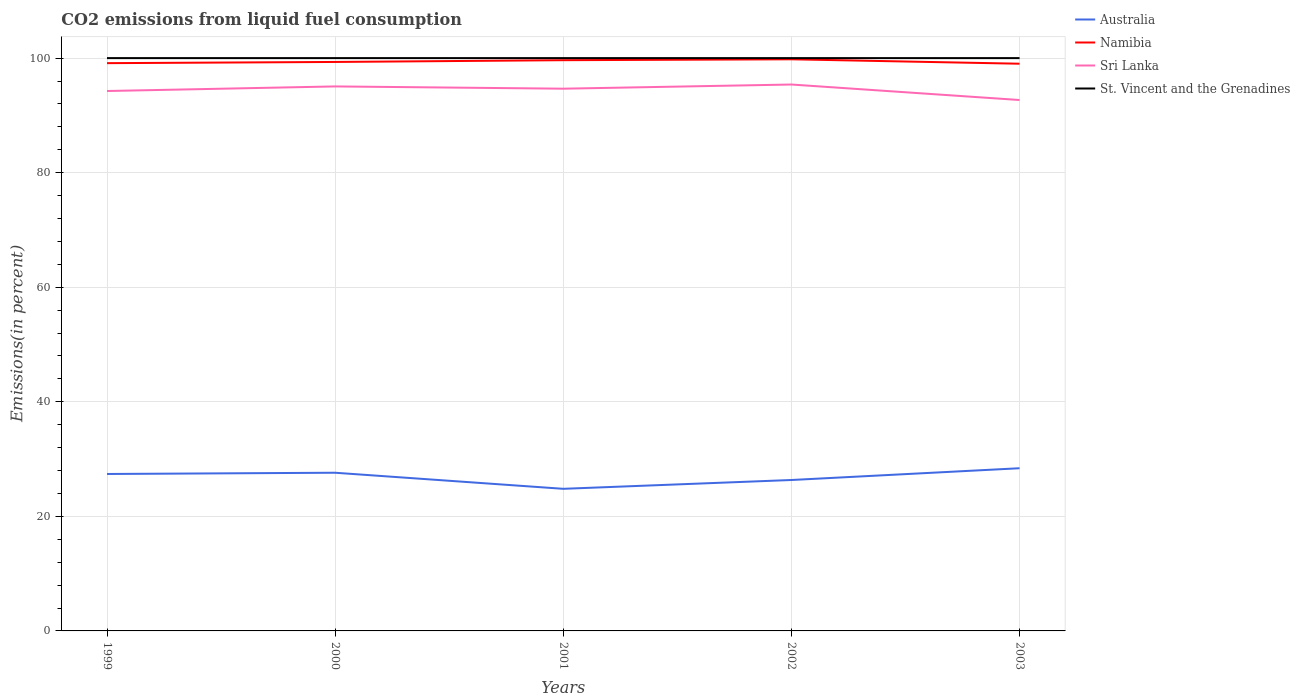How many different coloured lines are there?
Give a very brief answer. 4. Does the line corresponding to Australia intersect with the line corresponding to Namibia?
Your response must be concise. No. Is the number of lines equal to the number of legend labels?
Provide a succinct answer. Yes. Across all years, what is the maximum total CO2 emitted in Sri Lanka?
Ensure brevity in your answer.  92.68. In which year was the total CO2 emitted in St. Vincent and the Grenadines maximum?
Your answer should be compact. 1999. What is the total total CO2 emitted in St. Vincent and the Grenadines in the graph?
Your answer should be very brief. 0. Is the total CO2 emitted in Namibia strictly greater than the total CO2 emitted in St. Vincent and the Grenadines over the years?
Your answer should be compact. Yes. How many years are there in the graph?
Your response must be concise. 5. What is the difference between two consecutive major ticks on the Y-axis?
Give a very brief answer. 20. Are the values on the major ticks of Y-axis written in scientific E-notation?
Your response must be concise. No. Does the graph contain grids?
Provide a short and direct response. Yes. Where does the legend appear in the graph?
Provide a succinct answer. Top right. How many legend labels are there?
Keep it short and to the point. 4. What is the title of the graph?
Offer a very short reply. CO2 emissions from liquid fuel consumption. What is the label or title of the Y-axis?
Offer a very short reply. Emissions(in percent). What is the Emissions(in percent) of Australia in 1999?
Keep it short and to the point. 27.4. What is the Emissions(in percent) in Namibia in 1999?
Your response must be concise. 99.12. What is the Emissions(in percent) in Sri Lanka in 1999?
Make the answer very short. 94.26. What is the Emissions(in percent) in St. Vincent and the Grenadines in 1999?
Ensure brevity in your answer.  100. What is the Emissions(in percent) of Australia in 2000?
Provide a succinct answer. 27.61. What is the Emissions(in percent) of Namibia in 2000?
Offer a terse response. 99.33. What is the Emissions(in percent) of Sri Lanka in 2000?
Your response must be concise. 95.06. What is the Emissions(in percent) in Australia in 2001?
Keep it short and to the point. 24.81. What is the Emissions(in percent) in Namibia in 2001?
Provide a short and direct response. 99.64. What is the Emissions(in percent) in Sri Lanka in 2001?
Offer a terse response. 94.66. What is the Emissions(in percent) of St. Vincent and the Grenadines in 2001?
Offer a terse response. 100. What is the Emissions(in percent) in Australia in 2002?
Your answer should be compact. 26.35. What is the Emissions(in percent) of Namibia in 2002?
Your answer should be very brief. 99.79. What is the Emissions(in percent) of Sri Lanka in 2002?
Offer a terse response. 95.39. What is the Emissions(in percent) in St. Vincent and the Grenadines in 2002?
Provide a short and direct response. 100. What is the Emissions(in percent) of Australia in 2003?
Your answer should be compact. 28.4. What is the Emissions(in percent) of Namibia in 2003?
Your answer should be compact. 99.02. What is the Emissions(in percent) of Sri Lanka in 2003?
Provide a short and direct response. 92.68. Across all years, what is the maximum Emissions(in percent) in Australia?
Your response must be concise. 28.4. Across all years, what is the maximum Emissions(in percent) of Namibia?
Offer a very short reply. 99.79. Across all years, what is the maximum Emissions(in percent) of Sri Lanka?
Your response must be concise. 95.39. Across all years, what is the minimum Emissions(in percent) of Australia?
Ensure brevity in your answer.  24.81. Across all years, what is the minimum Emissions(in percent) of Namibia?
Your answer should be very brief. 99.02. Across all years, what is the minimum Emissions(in percent) in Sri Lanka?
Your answer should be very brief. 92.68. What is the total Emissions(in percent) of Australia in the graph?
Offer a very short reply. 134.57. What is the total Emissions(in percent) in Namibia in the graph?
Your answer should be compact. 496.9. What is the total Emissions(in percent) of Sri Lanka in the graph?
Provide a short and direct response. 472.05. What is the difference between the Emissions(in percent) of Australia in 1999 and that in 2000?
Your response must be concise. -0.22. What is the difference between the Emissions(in percent) in Namibia in 1999 and that in 2000?
Offer a terse response. -0.21. What is the difference between the Emissions(in percent) in Sri Lanka in 1999 and that in 2000?
Your answer should be very brief. -0.8. What is the difference between the Emissions(in percent) of St. Vincent and the Grenadines in 1999 and that in 2000?
Ensure brevity in your answer.  0. What is the difference between the Emissions(in percent) of Australia in 1999 and that in 2001?
Make the answer very short. 2.59. What is the difference between the Emissions(in percent) in Namibia in 1999 and that in 2001?
Offer a very short reply. -0.52. What is the difference between the Emissions(in percent) in Sri Lanka in 1999 and that in 2001?
Offer a very short reply. -0.41. What is the difference between the Emissions(in percent) in Australia in 1999 and that in 2002?
Your answer should be very brief. 1.05. What is the difference between the Emissions(in percent) of Namibia in 1999 and that in 2002?
Keep it short and to the point. -0.67. What is the difference between the Emissions(in percent) of Sri Lanka in 1999 and that in 2002?
Offer a very short reply. -1.13. What is the difference between the Emissions(in percent) of St. Vincent and the Grenadines in 1999 and that in 2002?
Your answer should be very brief. 0. What is the difference between the Emissions(in percent) in Australia in 1999 and that in 2003?
Provide a short and direct response. -1. What is the difference between the Emissions(in percent) of Namibia in 1999 and that in 2003?
Provide a succinct answer. 0.1. What is the difference between the Emissions(in percent) of Sri Lanka in 1999 and that in 2003?
Offer a terse response. 1.57. What is the difference between the Emissions(in percent) in St. Vincent and the Grenadines in 1999 and that in 2003?
Your answer should be compact. 0. What is the difference between the Emissions(in percent) of Australia in 2000 and that in 2001?
Your answer should be very brief. 2.81. What is the difference between the Emissions(in percent) of Namibia in 2000 and that in 2001?
Offer a very short reply. -0.31. What is the difference between the Emissions(in percent) in Sri Lanka in 2000 and that in 2001?
Make the answer very short. 0.39. What is the difference between the Emissions(in percent) of St. Vincent and the Grenadines in 2000 and that in 2001?
Your answer should be compact. 0. What is the difference between the Emissions(in percent) of Australia in 2000 and that in 2002?
Your response must be concise. 1.27. What is the difference between the Emissions(in percent) in Namibia in 2000 and that in 2002?
Make the answer very short. -0.46. What is the difference between the Emissions(in percent) in Sri Lanka in 2000 and that in 2002?
Keep it short and to the point. -0.33. What is the difference between the Emissions(in percent) in Australia in 2000 and that in 2003?
Your response must be concise. -0.79. What is the difference between the Emissions(in percent) in Namibia in 2000 and that in 2003?
Keep it short and to the point. 0.31. What is the difference between the Emissions(in percent) of Sri Lanka in 2000 and that in 2003?
Give a very brief answer. 2.37. What is the difference between the Emissions(in percent) of St. Vincent and the Grenadines in 2000 and that in 2003?
Your answer should be compact. 0. What is the difference between the Emissions(in percent) in Australia in 2001 and that in 2002?
Provide a succinct answer. -1.54. What is the difference between the Emissions(in percent) in Namibia in 2001 and that in 2002?
Your answer should be compact. -0.16. What is the difference between the Emissions(in percent) of Sri Lanka in 2001 and that in 2002?
Make the answer very short. -0.73. What is the difference between the Emissions(in percent) of St. Vincent and the Grenadines in 2001 and that in 2002?
Give a very brief answer. 0. What is the difference between the Emissions(in percent) in Australia in 2001 and that in 2003?
Ensure brevity in your answer.  -3.59. What is the difference between the Emissions(in percent) in Namibia in 2001 and that in 2003?
Ensure brevity in your answer.  0.61. What is the difference between the Emissions(in percent) of Sri Lanka in 2001 and that in 2003?
Ensure brevity in your answer.  1.98. What is the difference between the Emissions(in percent) of Australia in 2002 and that in 2003?
Give a very brief answer. -2.06. What is the difference between the Emissions(in percent) of Namibia in 2002 and that in 2003?
Provide a succinct answer. 0.77. What is the difference between the Emissions(in percent) of Sri Lanka in 2002 and that in 2003?
Provide a succinct answer. 2.71. What is the difference between the Emissions(in percent) in St. Vincent and the Grenadines in 2002 and that in 2003?
Ensure brevity in your answer.  0. What is the difference between the Emissions(in percent) in Australia in 1999 and the Emissions(in percent) in Namibia in 2000?
Ensure brevity in your answer.  -71.93. What is the difference between the Emissions(in percent) in Australia in 1999 and the Emissions(in percent) in Sri Lanka in 2000?
Your answer should be very brief. -67.66. What is the difference between the Emissions(in percent) in Australia in 1999 and the Emissions(in percent) in St. Vincent and the Grenadines in 2000?
Provide a short and direct response. -72.6. What is the difference between the Emissions(in percent) in Namibia in 1999 and the Emissions(in percent) in Sri Lanka in 2000?
Your answer should be very brief. 4.06. What is the difference between the Emissions(in percent) of Namibia in 1999 and the Emissions(in percent) of St. Vincent and the Grenadines in 2000?
Provide a short and direct response. -0.88. What is the difference between the Emissions(in percent) of Sri Lanka in 1999 and the Emissions(in percent) of St. Vincent and the Grenadines in 2000?
Your answer should be compact. -5.74. What is the difference between the Emissions(in percent) in Australia in 1999 and the Emissions(in percent) in Namibia in 2001?
Give a very brief answer. -72.24. What is the difference between the Emissions(in percent) in Australia in 1999 and the Emissions(in percent) in Sri Lanka in 2001?
Make the answer very short. -67.26. What is the difference between the Emissions(in percent) of Australia in 1999 and the Emissions(in percent) of St. Vincent and the Grenadines in 2001?
Your answer should be very brief. -72.6. What is the difference between the Emissions(in percent) in Namibia in 1999 and the Emissions(in percent) in Sri Lanka in 2001?
Ensure brevity in your answer.  4.46. What is the difference between the Emissions(in percent) of Namibia in 1999 and the Emissions(in percent) of St. Vincent and the Grenadines in 2001?
Offer a terse response. -0.88. What is the difference between the Emissions(in percent) in Sri Lanka in 1999 and the Emissions(in percent) in St. Vincent and the Grenadines in 2001?
Keep it short and to the point. -5.74. What is the difference between the Emissions(in percent) in Australia in 1999 and the Emissions(in percent) in Namibia in 2002?
Offer a very short reply. -72.39. What is the difference between the Emissions(in percent) in Australia in 1999 and the Emissions(in percent) in Sri Lanka in 2002?
Your answer should be compact. -67.99. What is the difference between the Emissions(in percent) of Australia in 1999 and the Emissions(in percent) of St. Vincent and the Grenadines in 2002?
Your response must be concise. -72.6. What is the difference between the Emissions(in percent) of Namibia in 1999 and the Emissions(in percent) of Sri Lanka in 2002?
Offer a terse response. 3.73. What is the difference between the Emissions(in percent) in Namibia in 1999 and the Emissions(in percent) in St. Vincent and the Grenadines in 2002?
Keep it short and to the point. -0.88. What is the difference between the Emissions(in percent) in Sri Lanka in 1999 and the Emissions(in percent) in St. Vincent and the Grenadines in 2002?
Your answer should be very brief. -5.74. What is the difference between the Emissions(in percent) in Australia in 1999 and the Emissions(in percent) in Namibia in 2003?
Your answer should be very brief. -71.62. What is the difference between the Emissions(in percent) in Australia in 1999 and the Emissions(in percent) in Sri Lanka in 2003?
Offer a very short reply. -65.29. What is the difference between the Emissions(in percent) of Australia in 1999 and the Emissions(in percent) of St. Vincent and the Grenadines in 2003?
Ensure brevity in your answer.  -72.6. What is the difference between the Emissions(in percent) in Namibia in 1999 and the Emissions(in percent) in Sri Lanka in 2003?
Your answer should be compact. 6.43. What is the difference between the Emissions(in percent) in Namibia in 1999 and the Emissions(in percent) in St. Vincent and the Grenadines in 2003?
Make the answer very short. -0.88. What is the difference between the Emissions(in percent) in Sri Lanka in 1999 and the Emissions(in percent) in St. Vincent and the Grenadines in 2003?
Offer a terse response. -5.74. What is the difference between the Emissions(in percent) of Australia in 2000 and the Emissions(in percent) of Namibia in 2001?
Give a very brief answer. -72.02. What is the difference between the Emissions(in percent) of Australia in 2000 and the Emissions(in percent) of Sri Lanka in 2001?
Provide a succinct answer. -67.05. What is the difference between the Emissions(in percent) in Australia in 2000 and the Emissions(in percent) in St. Vincent and the Grenadines in 2001?
Your response must be concise. -72.39. What is the difference between the Emissions(in percent) of Namibia in 2000 and the Emissions(in percent) of Sri Lanka in 2001?
Keep it short and to the point. 4.67. What is the difference between the Emissions(in percent) in Namibia in 2000 and the Emissions(in percent) in St. Vincent and the Grenadines in 2001?
Offer a very short reply. -0.67. What is the difference between the Emissions(in percent) in Sri Lanka in 2000 and the Emissions(in percent) in St. Vincent and the Grenadines in 2001?
Make the answer very short. -4.94. What is the difference between the Emissions(in percent) in Australia in 2000 and the Emissions(in percent) in Namibia in 2002?
Your answer should be very brief. -72.18. What is the difference between the Emissions(in percent) of Australia in 2000 and the Emissions(in percent) of Sri Lanka in 2002?
Give a very brief answer. -67.77. What is the difference between the Emissions(in percent) in Australia in 2000 and the Emissions(in percent) in St. Vincent and the Grenadines in 2002?
Ensure brevity in your answer.  -72.39. What is the difference between the Emissions(in percent) in Namibia in 2000 and the Emissions(in percent) in Sri Lanka in 2002?
Keep it short and to the point. 3.94. What is the difference between the Emissions(in percent) in Namibia in 2000 and the Emissions(in percent) in St. Vincent and the Grenadines in 2002?
Provide a succinct answer. -0.67. What is the difference between the Emissions(in percent) in Sri Lanka in 2000 and the Emissions(in percent) in St. Vincent and the Grenadines in 2002?
Keep it short and to the point. -4.94. What is the difference between the Emissions(in percent) in Australia in 2000 and the Emissions(in percent) in Namibia in 2003?
Give a very brief answer. -71.41. What is the difference between the Emissions(in percent) in Australia in 2000 and the Emissions(in percent) in Sri Lanka in 2003?
Offer a terse response. -65.07. What is the difference between the Emissions(in percent) in Australia in 2000 and the Emissions(in percent) in St. Vincent and the Grenadines in 2003?
Offer a terse response. -72.39. What is the difference between the Emissions(in percent) of Namibia in 2000 and the Emissions(in percent) of Sri Lanka in 2003?
Keep it short and to the point. 6.65. What is the difference between the Emissions(in percent) in Namibia in 2000 and the Emissions(in percent) in St. Vincent and the Grenadines in 2003?
Provide a short and direct response. -0.67. What is the difference between the Emissions(in percent) in Sri Lanka in 2000 and the Emissions(in percent) in St. Vincent and the Grenadines in 2003?
Your answer should be very brief. -4.94. What is the difference between the Emissions(in percent) in Australia in 2001 and the Emissions(in percent) in Namibia in 2002?
Your response must be concise. -74.98. What is the difference between the Emissions(in percent) in Australia in 2001 and the Emissions(in percent) in Sri Lanka in 2002?
Ensure brevity in your answer.  -70.58. What is the difference between the Emissions(in percent) in Australia in 2001 and the Emissions(in percent) in St. Vincent and the Grenadines in 2002?
Keep it short and to the point. -75.19. What is the difference between the Emissions(in percent) in Namibia in 2001 and the Emissions(in percent) in Sri Lanka in 2002?
Offer a terse response. 4.25. What is the difference between the Emissions(in percent) in Namibia in 2001 and the Emissions(in percent) in St. Vincent and the Grenadines in 2002?
Your response must be concise. -0.36. What is the difference between the Emissions(in percent) in Sri Lanka in 2001 and the Emissions(in percent) in St. Vincent and the Grenadines in 2002?
Offer a very short reply. -5.34. What is the difference between the Emissions(in percent) of Australia in 2001 and the Emissions(in percent) of Namibia in 2003?
Provide a succinct answer. -74.21. What is the difference between the Emissions(in percent) in Australia in 2001 and the Emissions(in percent) in Sri Lanka in 2003?
Provide a succinct answer. -67.88. What is the difference between the Emissions(in percent) in Australia in 2001 and the Emissions(in percent) in St. Vincent and the Grenadines in 2003?
Your response must be concise. -75.19. What is the difference between the Emissions(in percent) of Namibia in 2001 and the Emissions(in percent) of Sri Lanka in 2003?
Give a very brief answer. 6.95. What is the difference between the Emissions(in percent) in Namibia in 2001 and the Emissions(in percent) in St. Vincent and the Grenadines in 2003?
Your answer should be compact. -0.36. What is the difference between the Emissions(in percent) in Sri Lanka in 2001 and the Emissions(in percent) in St. Vincent and the Grenadines in 2003?
Ensure brevity in your answer.  -5.34. What is the difference between the Emissions(in percent) of Australia in 2002 and the Emissions(in percent) of Namibia in 2003?
Provide a short and direct response. -72.68. What is the difference between the Emissions(in percent) of Australia in 2002 and the Emissions(in percent) of Sri Lanka in 2003?
Make the answer very short. -66.34. What is the difference between the Emissions(in percent) of Australia in 2002 and the Emissions(in percent) of St. Vincent and the Grenadines in 2003?
Ensure brevity in your answer.  -73.65. What is the difference between the Emissions(in percent) in Namibia in 2002 and the Emissions(in percent) in Sri Lanka in 2003?
Provide a succinct answer. 7.11. What is the difference between the Emissions(in percent) of Namibia in 2002 and the Emissions(in percent) of St. Vincent and the Grenadines in 2003?
Offer a very short reply. -0.21. What is the difference between the Emissions(in percent) in Sri Lanka in 2002 and the Emissions(in percent) in St. Vincent and the Grenadines in 2003?
Your answer should be very brief. -4.61. What is the average Emissions(in percent) of Australia per year?
Your answer should be very brief. 26.91. What is the average Emissions(in percent) of Namibia per year?
Offer a terse response. 99.38. What is the average Emissions(in percent) of Sri Lanka per year?
Your response must be concise. 94.41. What is the average Emissions(in percent) in St. Vincent and the Grenadines per year?
Offer a terse response. 100. In the year 1999, what is the difference between the Emissions(in percent) in Australia and Emissions(in percent) in Namibia?
Make the answer very short. -71.72. In the year 1999, what is the difference between the Emissions(in percent) in Australia and Emissions(in percent) in Sri Lanka?
Offer a very short reply. -66.86. In the year 1999, what is the difference between the Emissions(in percent) of Australia and Emissions(in percent) of St. Vincent and the Grenadines?
Keep it short and to the point. -72.6. In the year 1999, what is the difference between the Emissions(in percent) in Namibia and Emissions(in percent) in Sri Lanka?
Offer a very short reply. 4.86. In the year 1999, what is the difference between the Emissions(in percent) of Namibia and Emissions(in percent) of St. Vincent and the Grenadines?
Your response must be concise. -0.88. In the year 1999, what is the difference between the Emissions(in percent) of Sri Lanka and Emissions(in percent) of St. Vincent and the Grenadines?
Offer a terse response. -5.74. In the year 2000, what is the difference between the Emissions(in percent) of Australia and Emissions(in percent) of Namibia?
Provide a succinct answer. -71.72. In the year 2000, what is the difference between the Emissions(in percent) in Australia and Emissions(in percent) in Sri Lanka?
Provide a short and direct response. -67.44. In the year 2000, what is the difference between the Emissions(in percent) in Australia and Emissions(in percent) in St. Vincent and the Grenadines?
Provide a succinct answer. -72.39. In the year 2000, what is the difference between the Emissions(in percent) of Namibia and Emissions(in percent) of Sri Lanka?
Offer a terse response. 4.27. In the year 2000, what is the difference between the Emissions(in percent) in Namibia and Emissions(in percent) in St. Vincent and the Grenadines?
Your answer should be very brief. -0.67. In the year 2000, what is the difference between the Emissions(in percent) of Sri Lanka and Emissions(in percent) of St. Vincent and the Grenadines?
Ensure brevity in your answer.  -4.94. In the year 2001, what is the difference between the Emissions(in percent) in Australia and Emissions(in percent) in Namibia?
Ensure brevity in your answer.  -74.83. In the year 2001, what is the difference between the Emissions(in percent) in Australia and Emissions(in percent) in Sri Lanka?
Offer a very short reply. -69.85. In the year 2001, what is the difference between the Emissions(in percent) of Australia and Emissions(in percent) of St. Vincent and the Grenadines?
Your answer should be very brief. -75.19. In the year 2001, what is the difference between the Emissions(in percent) of Namibia and Emissions(in percent) of Sri Lanka?
Make the answer very short. 4.97. In the year 2001, what is the difference between the Emissions(in percent) of Namibia and Emissions(in percent) of St. Vincent and the Grenadines?
Offer a very short reply. -0.36. In the year 2001, what is the difference between the Emissions(in percent) of Sri Lanka and Emissions(in percent) of St. Vincent and the Grenadines?
Your answer should be compact. -5.34. In the year 2002, what is the difference between the Emissions(in percent) of Australia and Emissions(in percent) of Namibia?
Your answer should be compact. -73.45. In the year 2002, what is the difference between the Emissions(in percent) in Australia and Emissions(in percent) in Sri Lanka?
Offer a very short reply. -69.04. In the year 2002, what is the difference between the Emissions(in percent) of Australia and Emissions(in percent) of St. Vincent and the Grenadines?
Provide a short and direct response. -73.65. In the year 2002, what is the difference between the Emissions(in percent) in Namibia and Emissions(in percent) in Sri Lanka?
Offer a very short reply. 4.4. In the year 2002, what is the difference between the Emissions(in percent) of Namibia and Emissions(in percent) of St. Vincent and the Grenadines?
Make the answer very short. -0.21. In the year 2002, what is the difference between the Emissions(in percent) of Sri Lanka and Emissions(in percent) of St. Vincent and the Grenadines?
Your answer should be compact. -4.61. In the year 2003, what is the difference between the Emissions(in percent) of Australia and Emissions(in percent) of Namibia?
Offer a very short reply. -70.62. In the year 2003, what is the difference between the Emissions(in percent) of Australia and Emissions(in percent) of Sri Lanka?
Give a very brief answer. -64.28. In the year 2003, what is the difference between the Emissions(in percent) in Australia and Emissions(in percent) in St. Vincent and the Grenadines?
Offer a terse response. -71.6. In the year 2003, what is the difference between the Emissions(in percent) in Namibia and Emissions(in percent) in Sri Lanka?
Keep it short and to the point. 6.34. In the year 2003, what is the difference between the Emissions(in percent) of Namibia and Emissions(in percent) of St. Vincent and the Grenadines?
Your answer should be very brief. -0.98. In the year 2003, what is the difference between the Emissions(in percent) in Sri Lanka and Emissions(in percent) in St. Vincent and the Grenadines?
Ensure brevity in your answer.  -7.32. What is the ratio of the Emissions(in percent) in Australia in 1999 to that in 2001?
Offer a terse response. 1.1. What is the ratio of the Emissions(in percent) in Namibia in 1999 to that in 2001?
Offer a very short reply. 0.99. What is the ratio of the Emissions(in percent) in Australia in 1999 to that in 2002?
Give a very brief answer. 1.04. What is the ratio of the Emissions(in percent) of Sri Lanka in 1999 to that in 2002?
Your answer should be very brief. 0.99. What is the ratio of the Emissions(in percent) of Australia in 1999 to that in 2003?
Provide a short and direct response. 0.96. What is the ratio of the Emissions(in percent) of Namibia in 1999 to that in 2003?
Ensure brevity in your answer.  1. What is the ratio of the Emissions(in percent) of Sri Lanka in 1999 to that in 2003?
Offer a very short reply. 1.02. What is the ratio of the Emissions(in percent) of St. Vincent and the Grenadines in 1999 to that in 2003?
Offer a very short reply. 1. What is the ratio of the Emissions(in percent) in Australia in 2000 to that in 2001?
Offer a terse response. 1.11. What is the ratio of the Emissions(in percent) of Namibia in 2000 to that in 2001?
Offer a terse response. 1. What is the ratio of the Emissions(in percent) in Sri Lanka in 2000 to that in 2001?
Your response must be concise. 1. What is the ratio of the Emissions(in percent) in St. Vincent and the Grenadines in 2000 to that in 2001?
Your answer should be very brief. 1. What is the ratio of the Emissions(in percent) in Australia in 2000 to that in 2002?
Give a very brief answer. 1.05. What is the ratio of the Emissions(in percent) in Namibia in 2000 to that in 2002?
Your answer should be compact. 1. What is the ratio of the Emissions(in percent) of Australia in 2000 to that in 2003?
Provide a succinct answer. 0.97. What is the ratio of the Emissions(in percent) of Sri Lanka in 2000 to that in 2003?
Your response must be concise. 1.03. What is the ratio of the Emissions(in percent) in St. Vincent and the Grenadines in 2000 to that in 2003?
Make the answer very short. 1. What is the ratio of the Emissions(in percent) of Australia in 2001 to that in 2002?
Your answer should be very brief. 0.94. What is the ratio of the Emissions(in percent) of Sri Lanka in 2001 to that in 2002?
Make the answer very short. 0.99. What is the ratio of the Emissions(in percent) of St. Vincent and the Grenadines in 2001 to that in 2002?
Your answer should be very brief. 1. What is the ratio of the Emissions(in percent) of Australia in 2001 to that in 2003?
Your answer should be very brief. 0.87. What is the ratio of the Emissions(in percent) in Namibia in 2001 to that in 2003?
Ensure brevity in your answer.  1.01. What is the ratio of the Emissions(in percent) in Sri Lanka in 2001 to that in 2003?
Keep it short and to the point. 1.02. What is the ratio of the Emissions(in percent) in Australia in 2002 to that in 2003?
Your answer should be compact. 0.93. What is the ratio of the Emissions(in percent) in Namibia in 2002 to that in 2003?
Offer a very short reply. 1.01. What is the ratio of the Emissions(in percent) of Sri Lanka in 2002 to that in 2003?
Your answer should be compact. 1.03. What is the ratio of the Emissions(in percent) of St. Vincent and the Grenadines in 2002 to that in 2003?
Make the answer very short. 1. What is the difference between the highest and the second highest Emissions(in percent) of Australia?
Give a very brief answer. 0.79. What is the difference between the highest and the second highest Emissions(in percent) of Namibia?
Provide a short and direct response. 0.16. What is the difference between the highest and the second highest Emissions(in percent) in Sri Lanka?
Offer a terse response. 0.33. What is the difference between the highest and the second highest Emissions(in percent) in St. Vincent and the Grenadines?
Ensure brevity in your answer.  0. What is the difference between the highest and the lowest Emissions(in percent) of Australia?
Keep it short and to the point. 3.59. What is the difference between the highest and the lowest Emissions(in percent) in Namibia?
Provide a short and direct response. 0.77. What is the difference between the highest and the lowest Emissions(in percent) of Sri Lanka?
Ensure brevity in your answer.  2.71. 